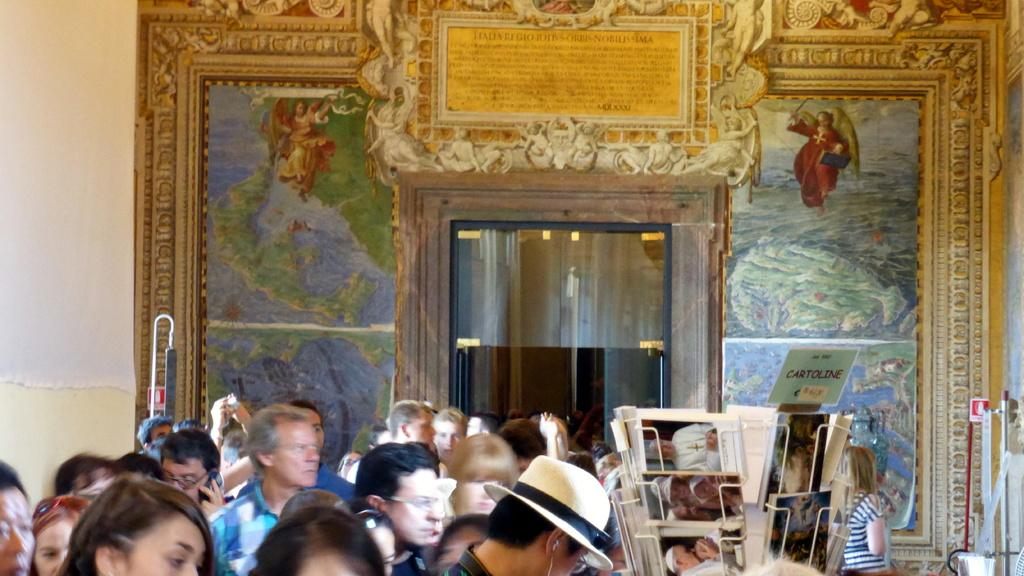How many people can be seen in the image? There are many people standing on the floor in the image. What is located in the middle of the image? There is a book rack in the middle of the image. What can be seen on the wall in the background of the image? There is a wall with paintings in the background of the image. What type of door is present in the wall in the background of the image? There is a glass door in the middle of the wall in the background of the image. What type of muscle is being exercised by the people in the image? There is no indication in the image that the people are exercising any muscles; they are simply standing on the floor. What nation is represented by the paintings on the wall in the background of the image? The image does not provide any information about the nation represented by the paintings on the wall. 